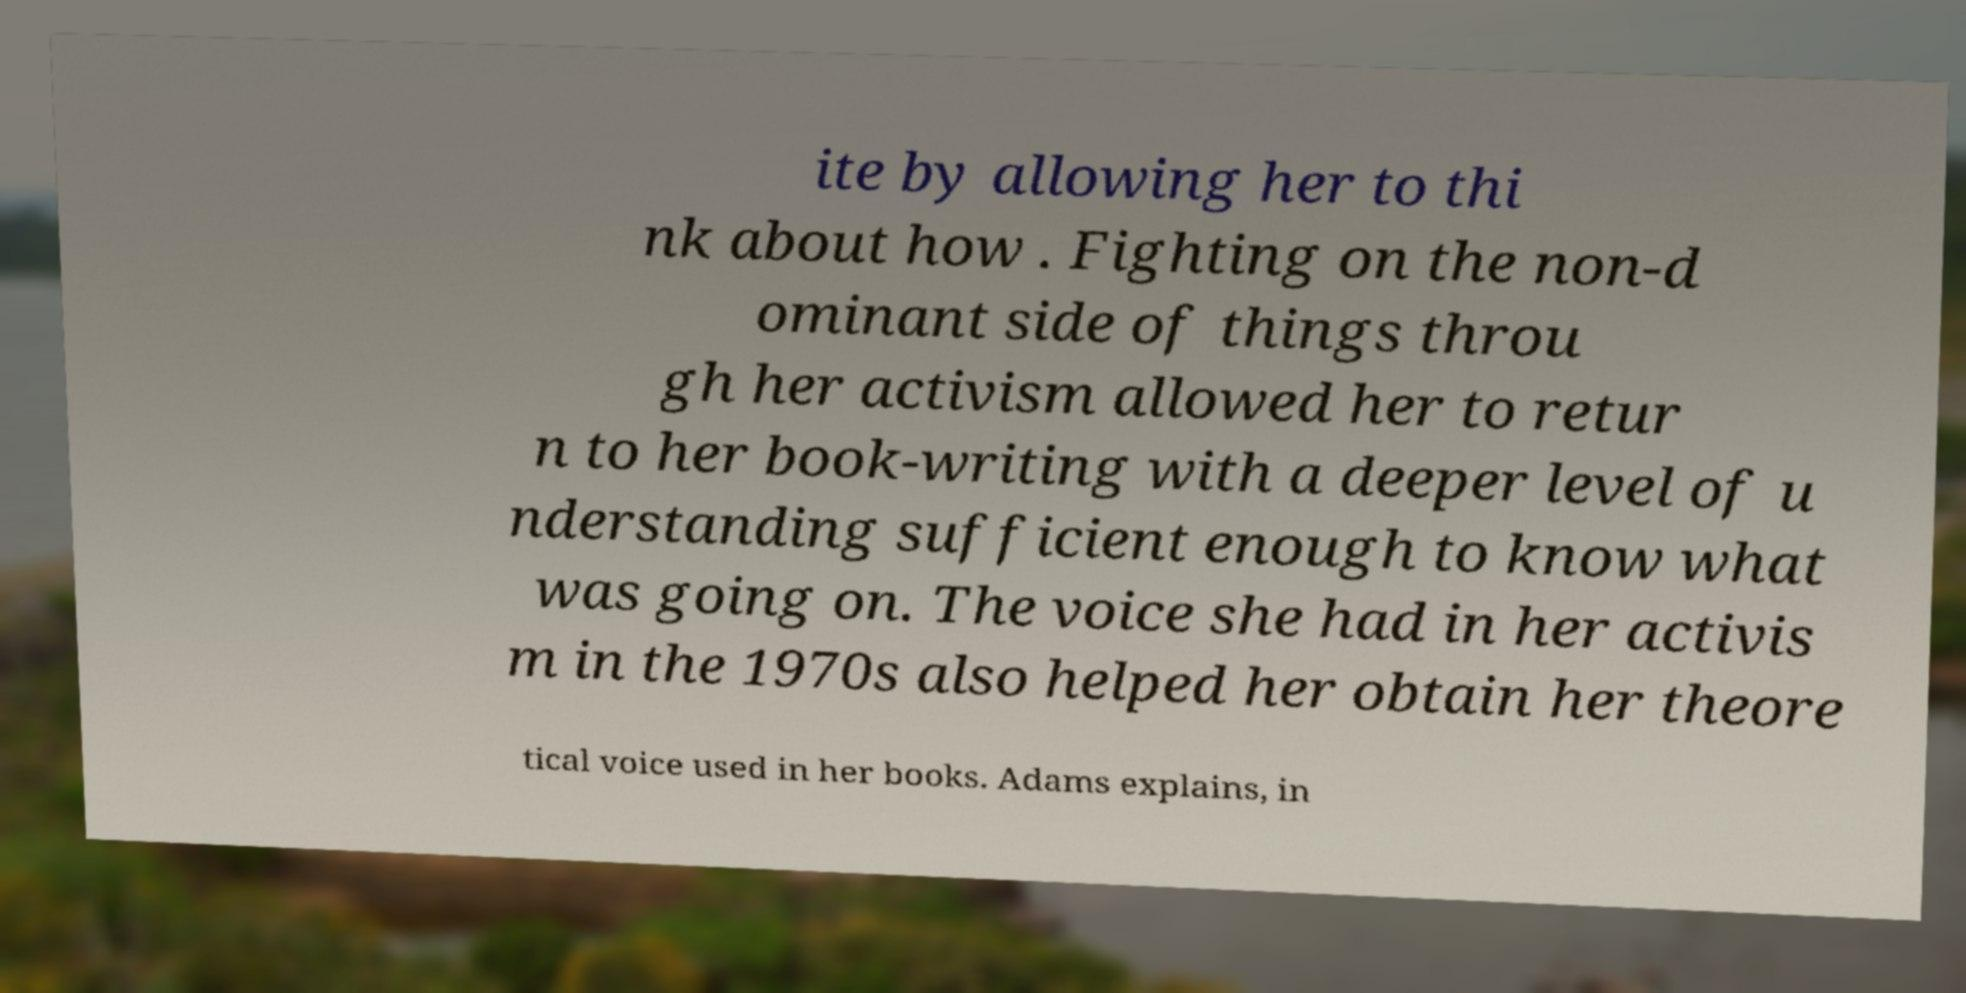Can you read and provide the text displayed in the image?This photo seems to have some interesting text. Can you extract and type it out for me? ite by allowing her to thi nk about how . Fighting on the non-d ominant side of things throu gh her activism allowed her to retur n to her book-writing with a deeper level of u nderstanding sufficient enough to know what was going on. The voice she had in her activis m in the 1970s also helped her obtain her theore tical voice used in her books. Adams explains, in 